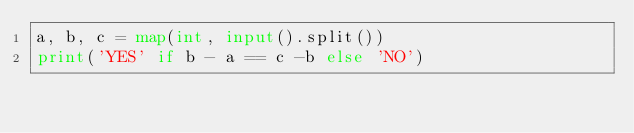<code> <loc_0><loc_0><loc_500><loc_500><_Python_>a, b, c = map(int, input().split())
print('YES' if b - a == c -b else 'NO')</code> 